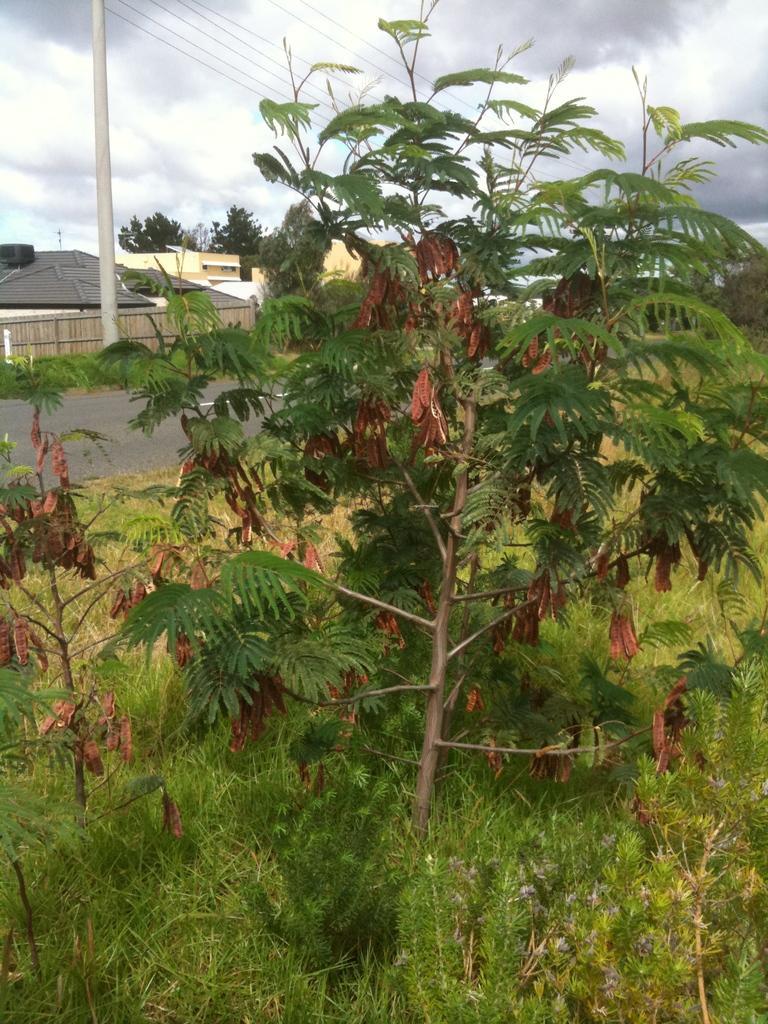Describe this image in one or two sentences. In the image we can see there are plants and trees on the ground. The ground is covered with grass and behind there are buildings. There is an electric pole on the ground and there is a cloudy sky. 